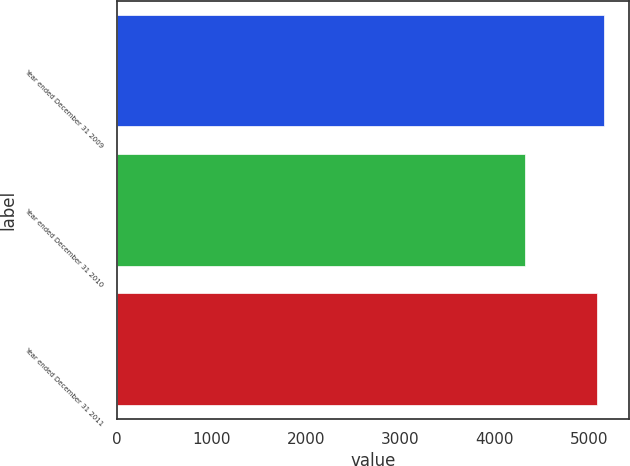Convert chart. <chart><loc_0><loc_0><loc_500><loc_500><bar_chart><fcel>Year ended December 31 2009<fcel>Year ended December 31 2010<fcel>Year ended December 31 2011<nl><fcel>5161.6<fcel>4326<fcel>5084<nl></chart> 